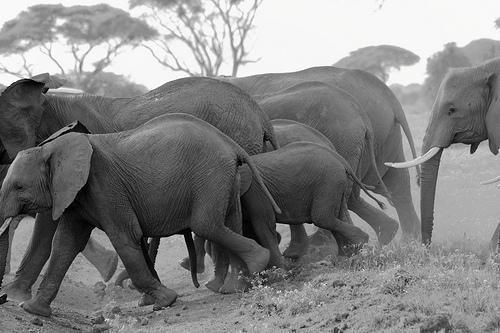How many elephants are shown?
Give a very brief answer. 7. How many elephants have task?
Give a very brief answer. 2. How many legs for each?
Give a very brief answer. 4. 